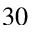Convert formula to latex. <formula><loc_0><loc_0><loc_500><loc_500>3 0</formula> 